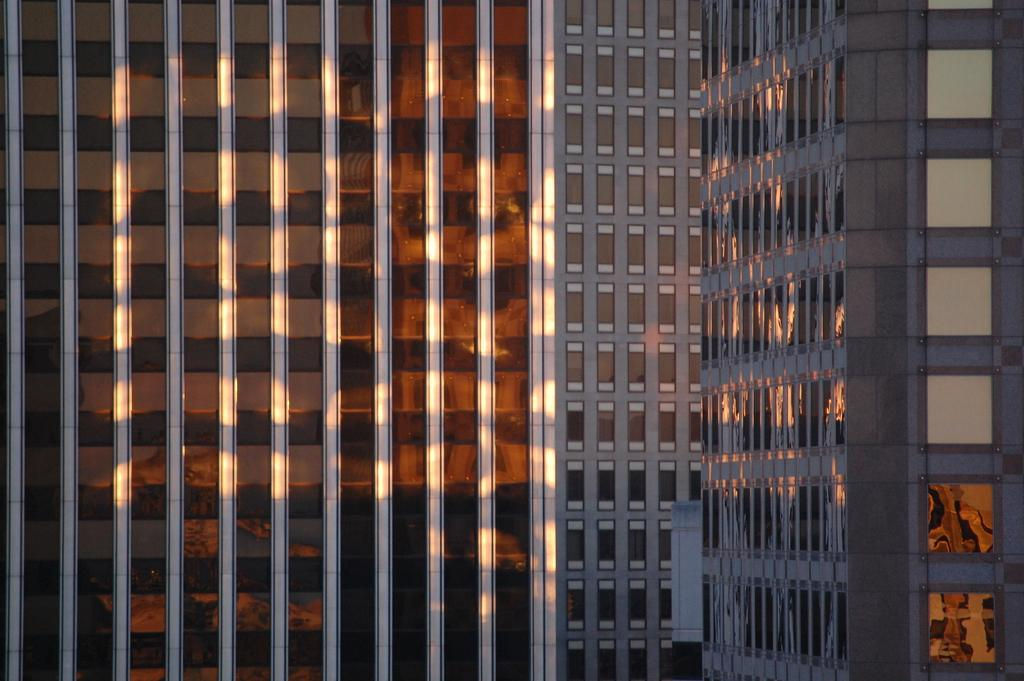What type of structures can be seen in the image? There are buildings in the image. What type of bucket is being used by the authority to promote development in the image? There is no bucket, authority, or development mentioned or depicted in the image. 